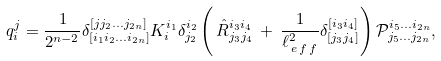<formula> <loc_0><loc_0><loc_500><loc_500>q _ { i } ^ { j } = \frac { 1 } { 2 ^ { n - 2 } } \delta _ { [ i _ { 1 } i _ { 2 } \dots i _ { 2 n } ] } ^ { [ j j _ { 2 } \dots j _ { 2 n } ] } K _ { i } ^ { i _ { 1 } } \delta _ { j _ { 2 } } ^ { i _ { 2 } } \left ( \, \hat { R } _ { j _ { 3 } j _ { 4 } } ^ { i _ { 3 } i _ { 4 } } \, + \, \frac { 1 } { \ell _ { \, e \, f \, f } ^ { 2 } } \delta _ { [ j _ { 3 } j _ { 4 } ] } ^ { [ i _ { 3 } i _ { 4 } ] } \right ) { \mathcal { P } } _ { j _ { 5 } \dots j _ { 2 n } } ^ { i _ { 5 } \dots i _ { 2 n } } ,</formula> 